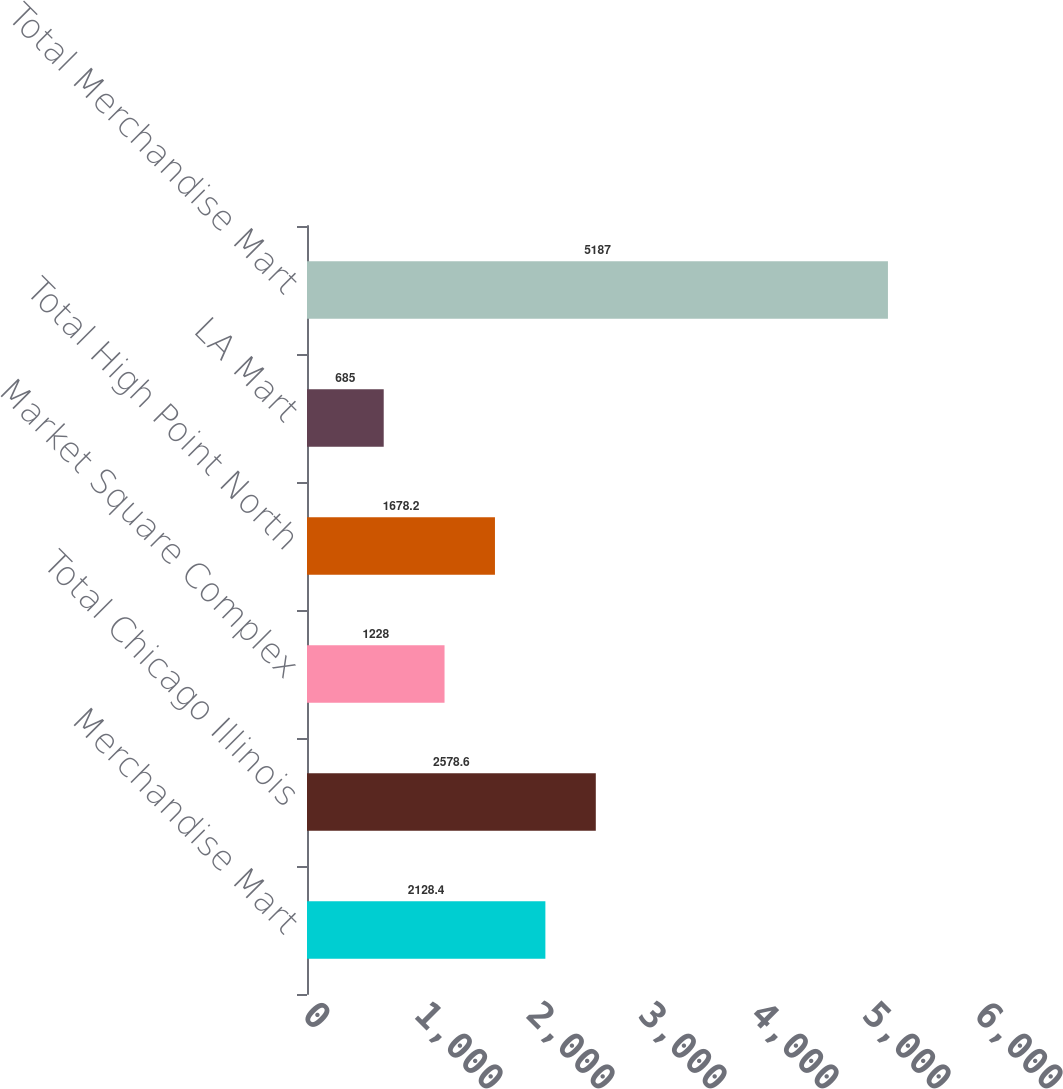Convert chart. <chart><loc_0><loc_0><loc_500><loc_500><bar_chart><fcel>Merchandise Mart<fcel>Total Chicago Illinois<fcel>Market Square Complex<fcel>Total High Point North<fcel>LA Mart<fcel>Total Merchandise Mart<nl><fcel>2128.4<fcel>2578.6<fcel>1228<fcel>1678.2<fcel>685<fcel>5187<nl></chart> 